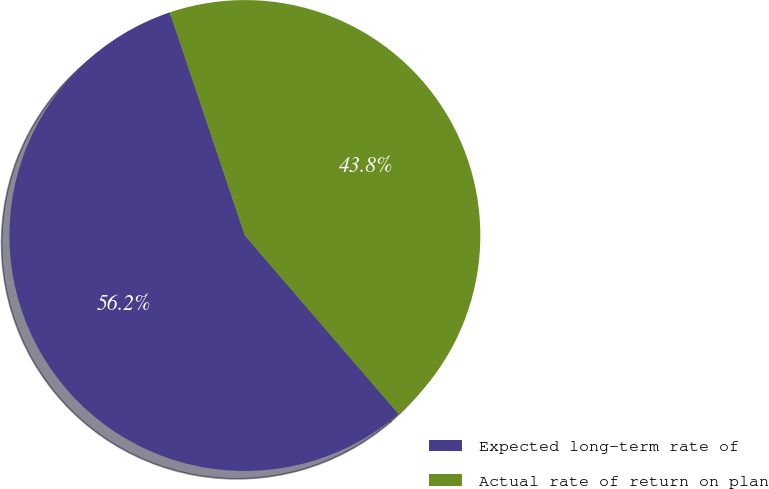Convert chart. <chart><loc_0><loc_0><loc_500><loc_500><pie_chart><fcel>Expected long-term rate of<fcel>Actual rate of return on plan<nl><fcel>56.15%<fcel>43.85%<nl></chart> 